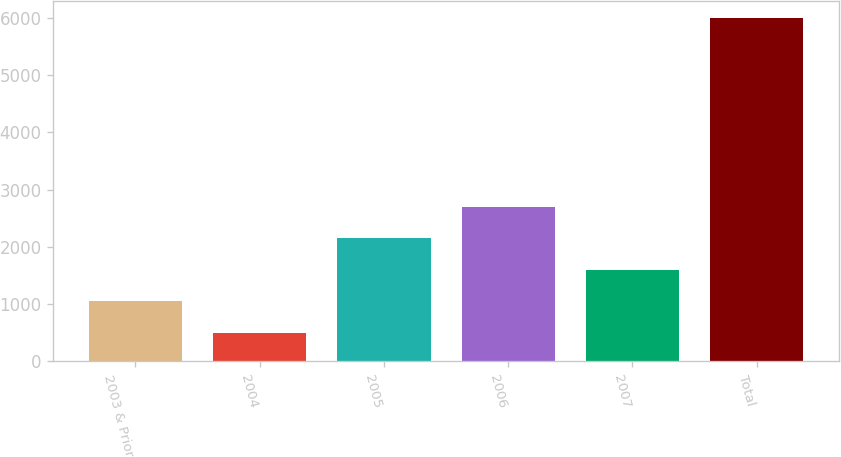<chart> <loc_0><loc_0><loc_500><loc_500><bar_chart><fcel>2003 & Prior<fcel>2004<fcel>2005<fcel>2006<fcel>2007<fcel>Total<nl><fcel>1051<fcel>502<fcel>2149<fcel>2698<fcel>1600<fcel>5992<nl></chart> 